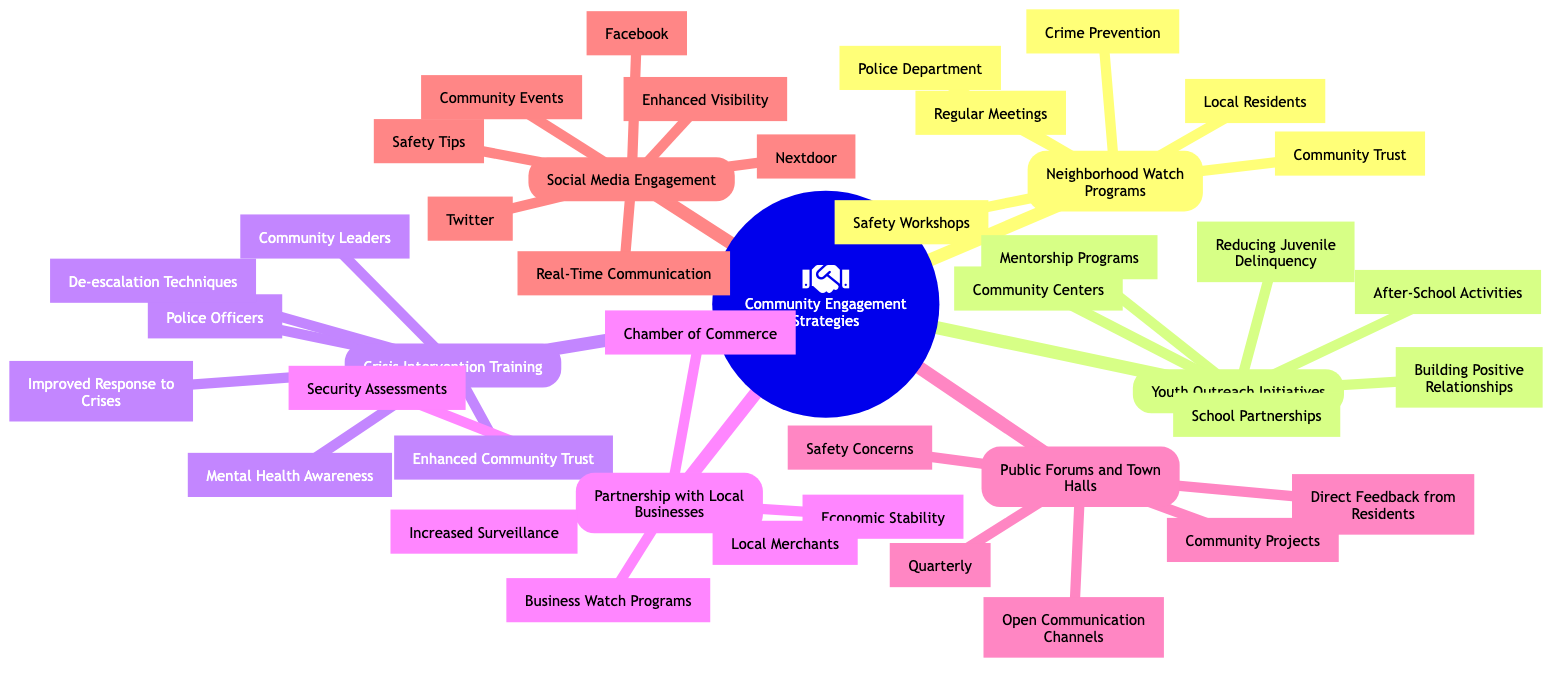What are the key partners in Neighborhood Watch Programs? The diagram identifies "Local Residents" and "Police Department" as key partners in Neighborhood Watch Programs. This information can be derived from the specific node connected to this strategy which outlines these partnerships.
Answer: Local Residents, Police Department How often are Public Forums and Town Halls held? The frequency of Public Forums and Town Halls is stated as "Quarterly" in the diagram. This information is located directly under the Public Forums and Town Halls node, providing a clear answer.
Answer: Quarterly What is the main goal of Youth Outreach Initiatives? Among the listed goals under Youth Outreach Initiatives, "Reducing Juvenile Delinquency" is the primary focus aimed at engaging the youth in the community. This is found directly in the relevant node of the mind map.
Answer: Reducing Juvenile Delinquency Which training module is included in Crisis Intervention Training? The diagram lists "De-escalation Techniques" as one of the training modules associated with Crisis Intervention Training. This information can be found directly in the corresponding section of the mind map.
Answer: De-escalation Techniques What type of programs are part of Youth Outreach Initiatives? The Youth Outreach Initiatives node mentions "Mentorship Programs" and "After-School Activities" as types of programs being offered. This can be directly seen under the Youth Outreach Initiatives section.
Answer: Mentorship Programs, After-School Activities What are the benefits of Partnership with Local Businesses? The advantages provided include "Increased Surveillance" and "Economic Stability," both found directly under the Partnership with Local Businesses node in the diagram.
Answer: Increased Surveillance, Economic Stability What is one of the outcomes of Crisis Intervention Training? One outcome specified under Crisis Intervention Training is "Improved Response to Crises," identifiable underneath this particular node in the mind map.
Answer: Improved Response to Crises What are the platforms used for Social Media Engagement? The platforms listed for Social Media Engagement include "Facebook," "Twitter," and "Nextdoor." These details are presented in the section dedicated to Social Media Engagement within the diagram.
Answer: Facebook, Twitter, Nextdoor What two activities are common in Neighborhood Watch Programs? The activities included in Neighborhood Watch Programs are "Regular Meetings" and "Safety Workshops," which are outlined in the node representing this strategy.
Answer: Regular Meetings, Safety Workshops 